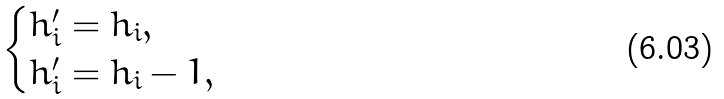<formula> <loc_0><loc_0><loc_500><loc_500>\begin{cases} h _ { i } ^ { \prime } = h _ { i } , & \\ h _ { i } ^ { \prime } = h _ { i } - 1 , & \end{cases}</formula> 